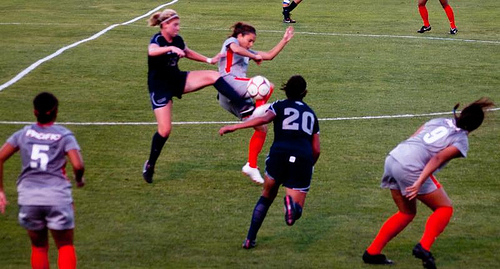<image>
Is there a woman to the left of the woman? No. The woman is not to the left of the woman. From this viewpoint, they have a different horizontal relationship. 